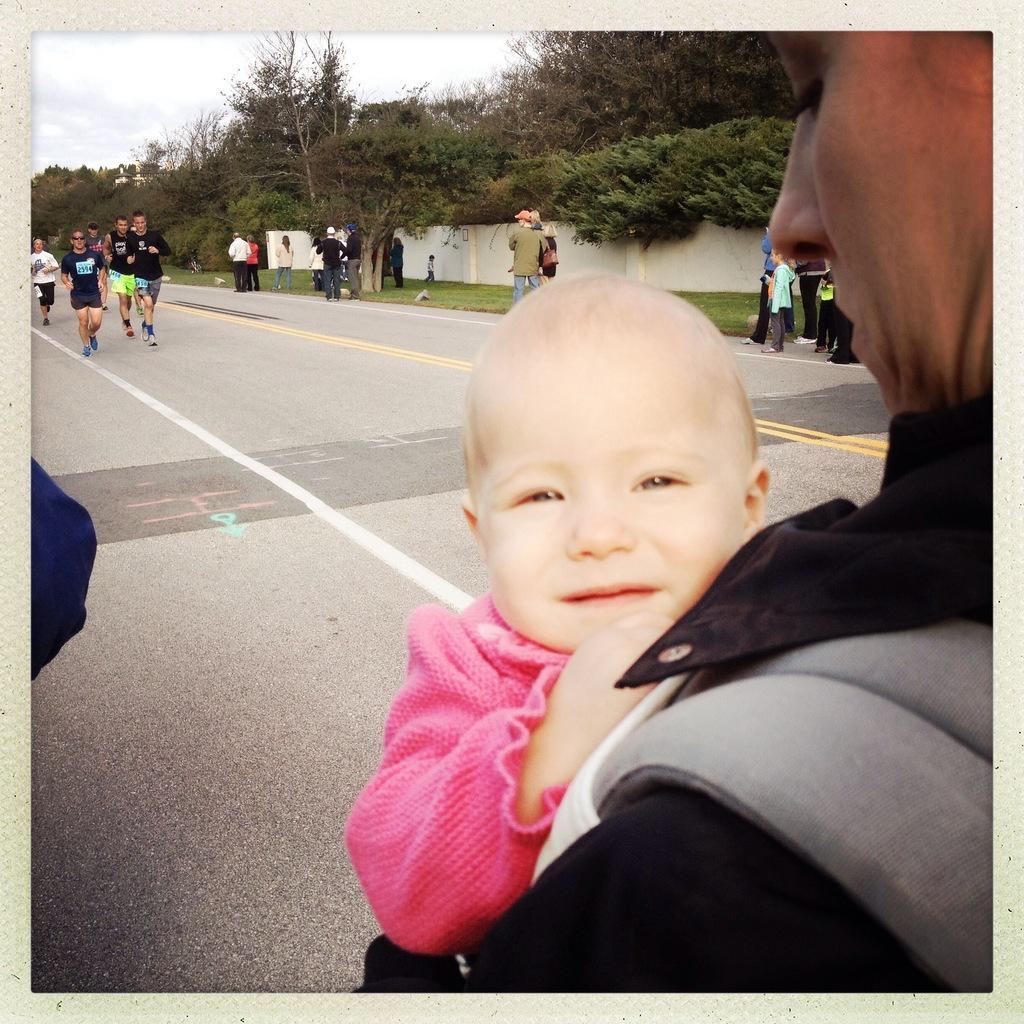Can you describe this image briefly? In this image we can see a group of people standing on the ground. One woman is carrying a baby in her hands. In the background, we can a wall, a group of trees and the sky 